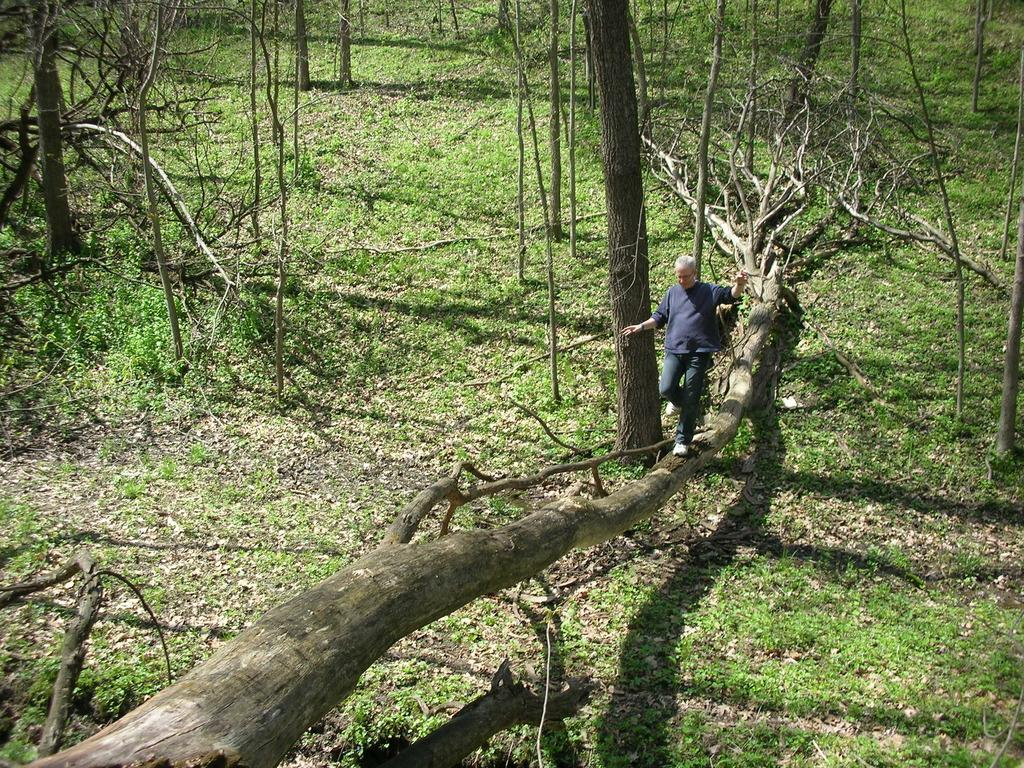What is the main action being performed by the person in the image? The person is walking in the image. What surface is the person walking on? The person is walking on a fallen tree trunk. What type of vegetation is visible in the image? There is grass visible in the image. What other natural elements can be seen in the image? There are trees in the image. What type of care is the person providing to the river in the image? There is no river present in the image, so the person cannot be providing care to a river. 